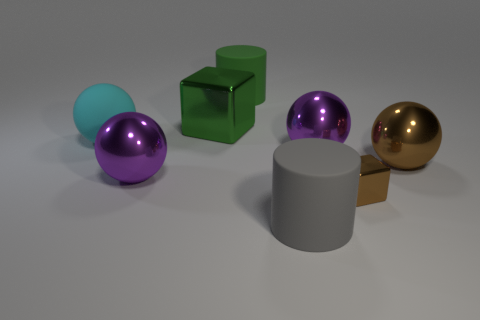Are there any other things that have the same size as the brown cube?
Ensure brevity in your answer.  No. Are there any other things of the same color as the small block?
Ensure brevity in your answer.  Yes. The large green thing that is the same material as the tiny brown cube is what shape?
Offer a very short reply. Cube. There is a sphere that is to the right of the green metal thing and on the left side of the brown shiny ball; what material is it made of?
Keep it short and to the point. Metal. Is the color of the small metal object the same as the large rubber ball?
Your answer should be compact. No. The big metallic thing that is the same color as the small metallic block is what shape?
Your answer should be compact. Sphere. What number of large brown things are the same shape as the cyan thing?
Offer a terse response. 1. The green thing that is made of the same material as the cyan object is what size?
Provide a short and direct response. Large. Do the cyan thing and the green rubber cylinder have the same size?
Your answer should be compact. Yes. Are there any large brown shiny balls?
Offer a very short reply. Yes. 